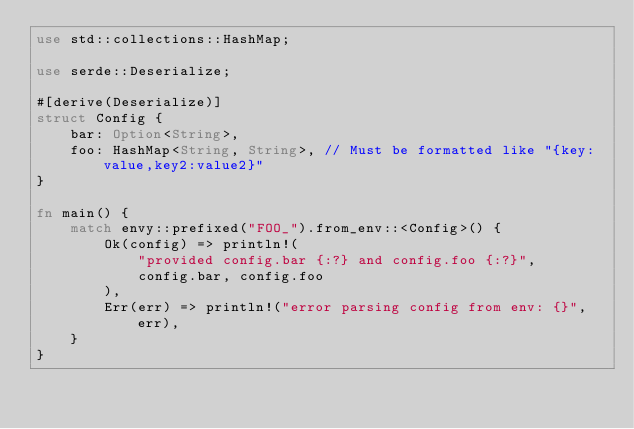<code> <loc_0><loc_0><loc_500><loc_500><_Rust_>use std::collections::HashMap;

use serde::Deserialize;

#[derive(Deserialize)]
struct Config {
    bar: Option<String>,
    foo: HashMap<String, String>, // Must be formatted like "{key:value,key2:value2}"
}

fn main() {
    match envy::prefixed("FOO_").from_env::<Config>() {
        Ok(config) => println!(
            "provided config.bar {:?} and config.foo {:?}",
            config.bar, config.foo
        ),
        Err(err) => println!("error parsing config from env: {}", err),
    }
}
</code> 